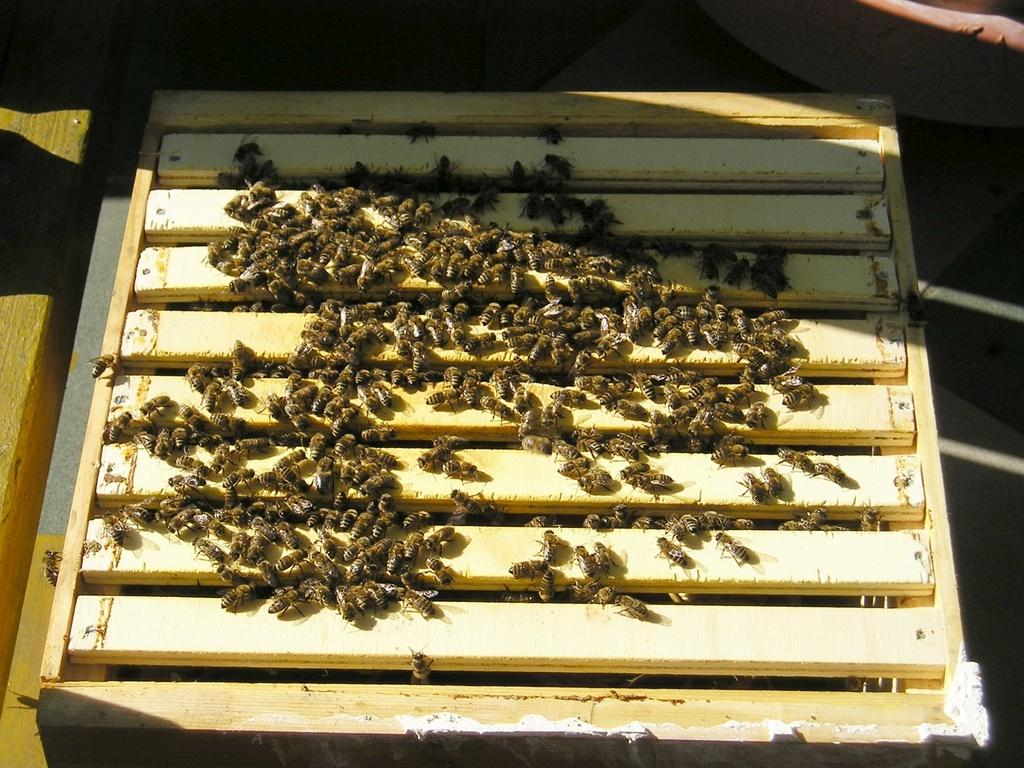What objects are present in the image? There are wooden sticks in the image. What is present on the wooden sticks? There is a group of honeybees on the wooden sticks. What part of the jeans can be seen in the image? There are no jeans present in the image. Can you tell me how many seashores are visible in the image? There is no seashore present in the image. 